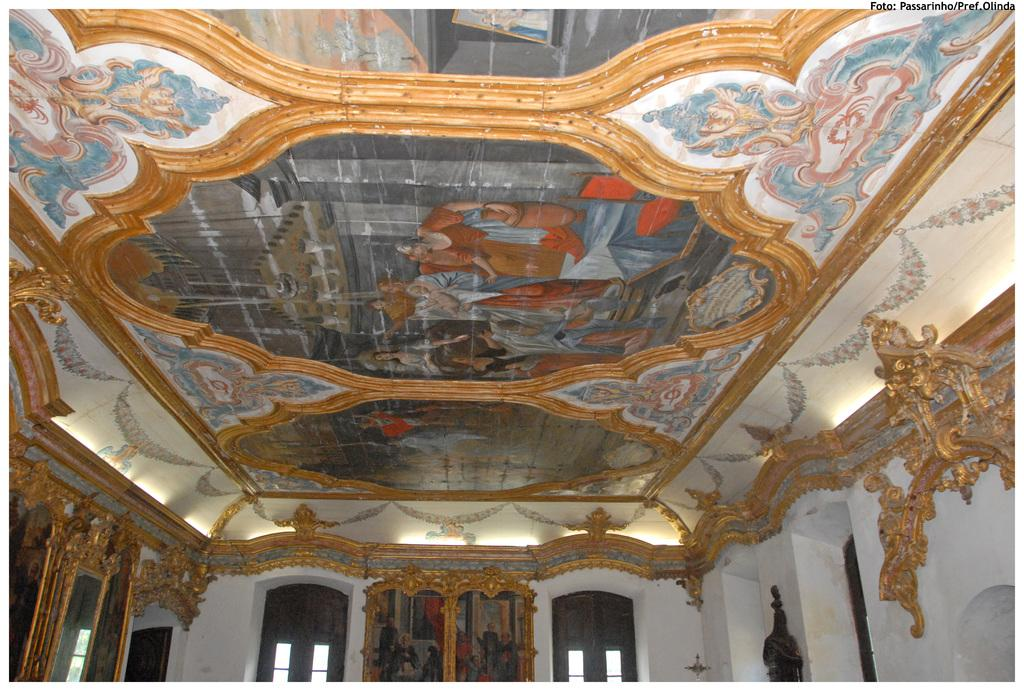What is depicted on the roof in the image? There are drawings on the roof in the image. What can be seen on the right side of the image? There are walls on the right side of the image. How many eyes can be seen in the image? There are no eyes visible in the image. What type of grass is growing on the walls in the image? There is no grass present in the image; it only features drawings on the roof and walls. 